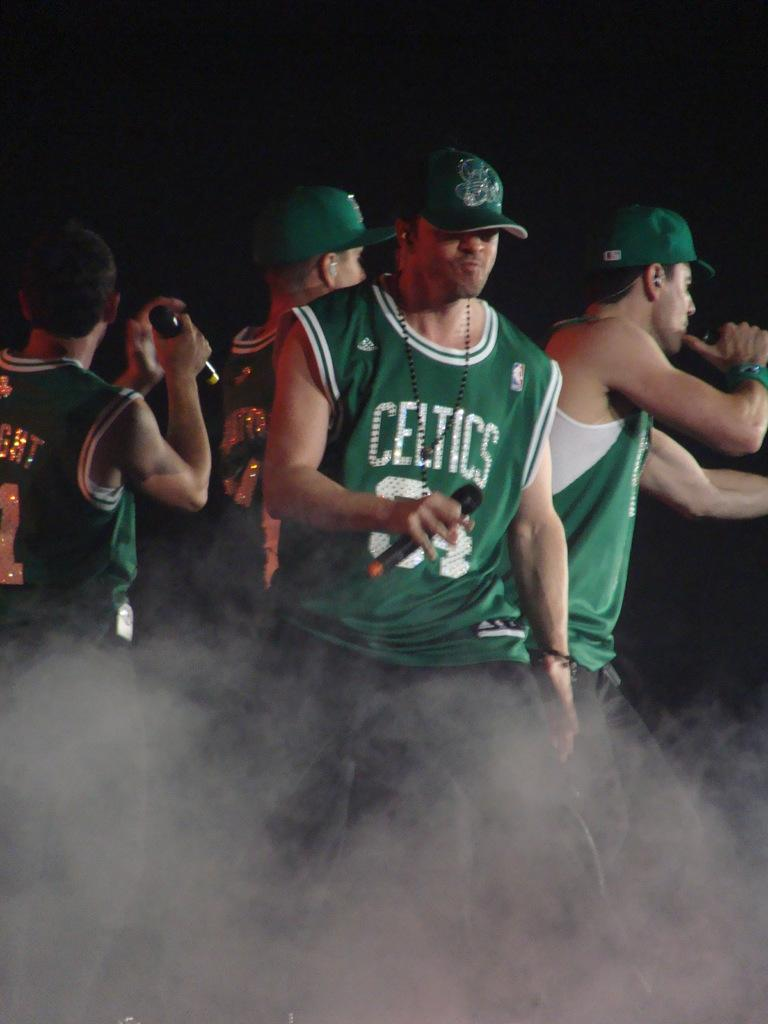Provide a one-sentence caption for the provided image. Men with microphones wearing green hats and green jerseys with the name Celtics on them. 